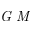<formula> <loc_0><loc_0><loc_500><loc_500>G M</formula> 